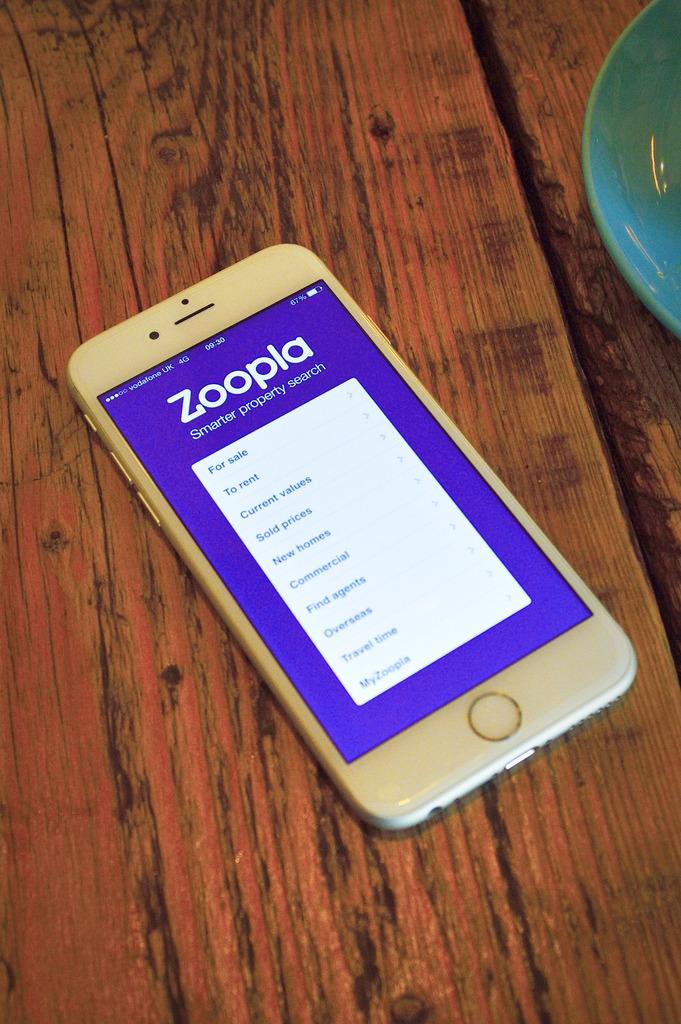What does the zoopla app do?
Offer a very short reply. Property search. What is the name of the app?
Provide a succinct answer. Zoopla. 